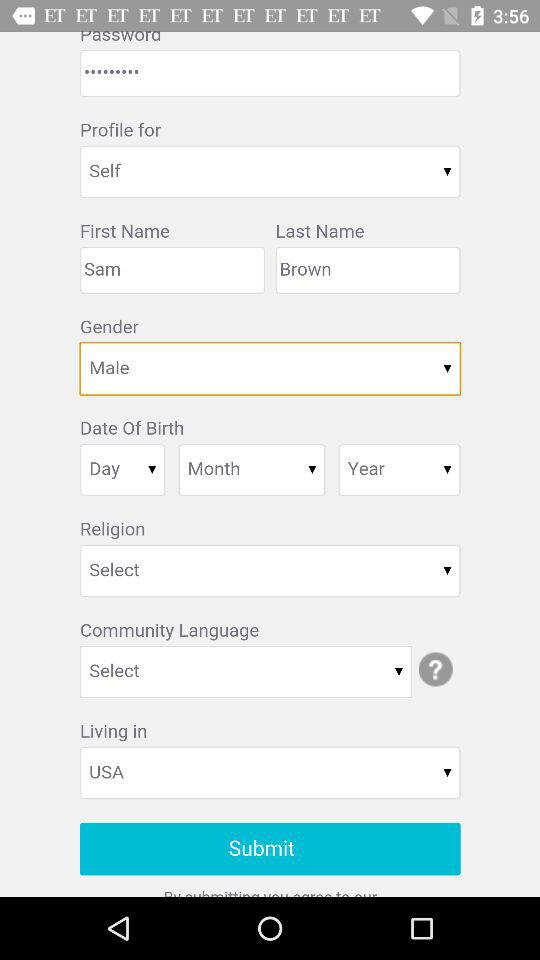What is the user's first name? The user's first name is Sam. 